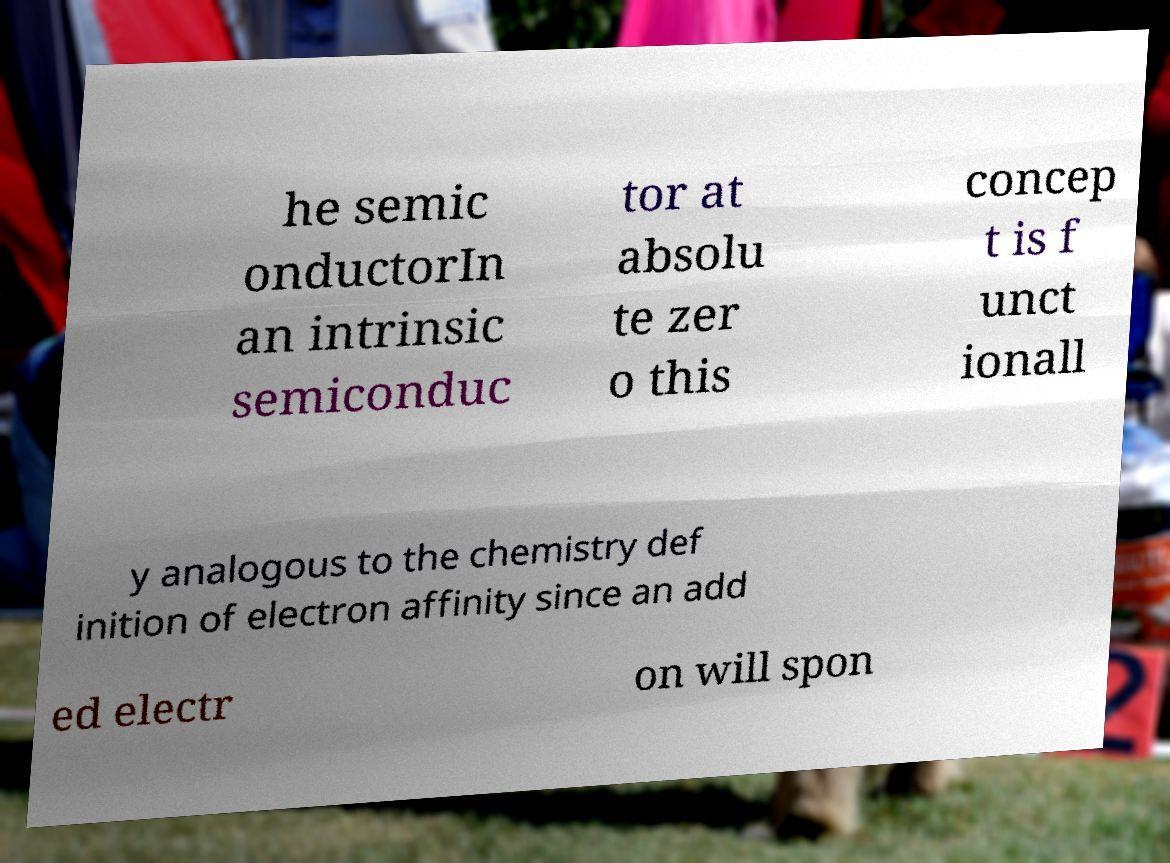For documentation purposes, I need the text within this image transcribed. Could you provide that? he semic onductorIn an intrinsic semiconduc tor at absolu te zer o this concep t is f unct ionall y analogous to the chemistry def inition of electron affinity since an add ed electr on will spon 